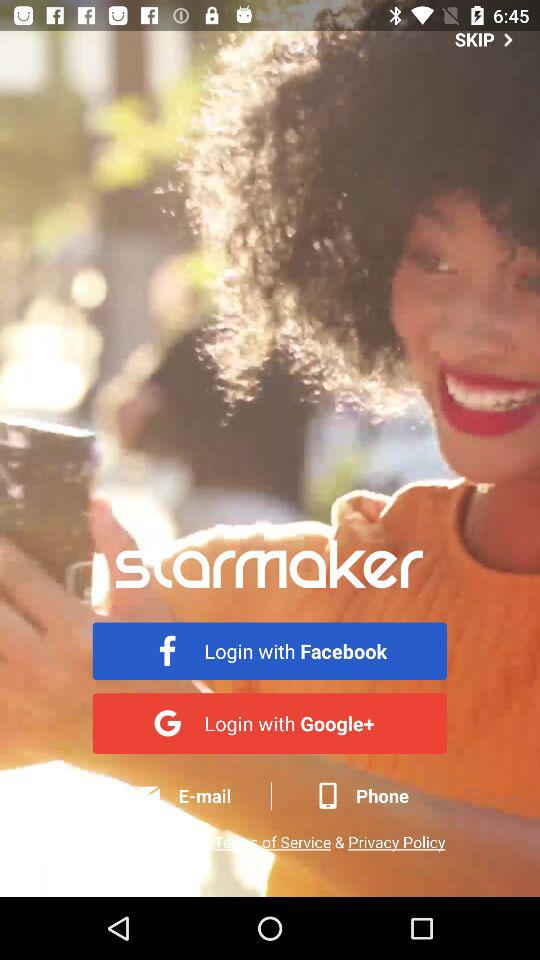What is the application name? The application name is "starmaker". 